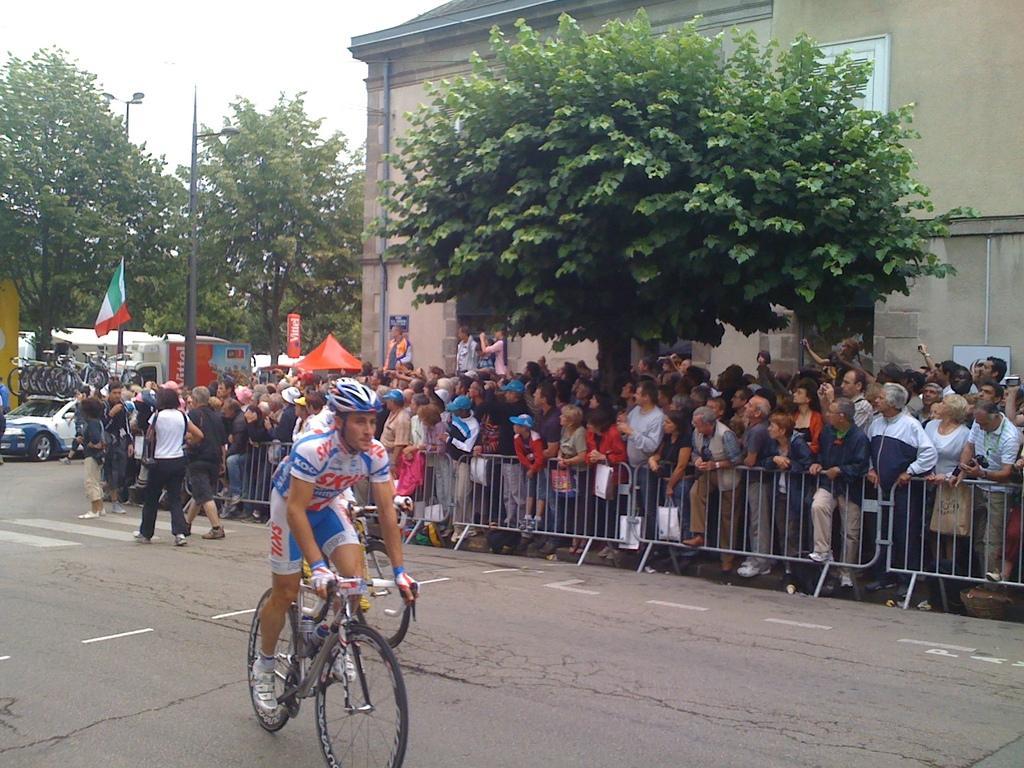In one or two sentences, can you explain what this image depicts? In this picture we can see a man riding a bicycle, he wore a helmet, in the background we can see barricades and group of people standing and looking at something and also there is a tree and building in the background, on the left most of the picture we can see a car and bicycles here and here there is a flag. 